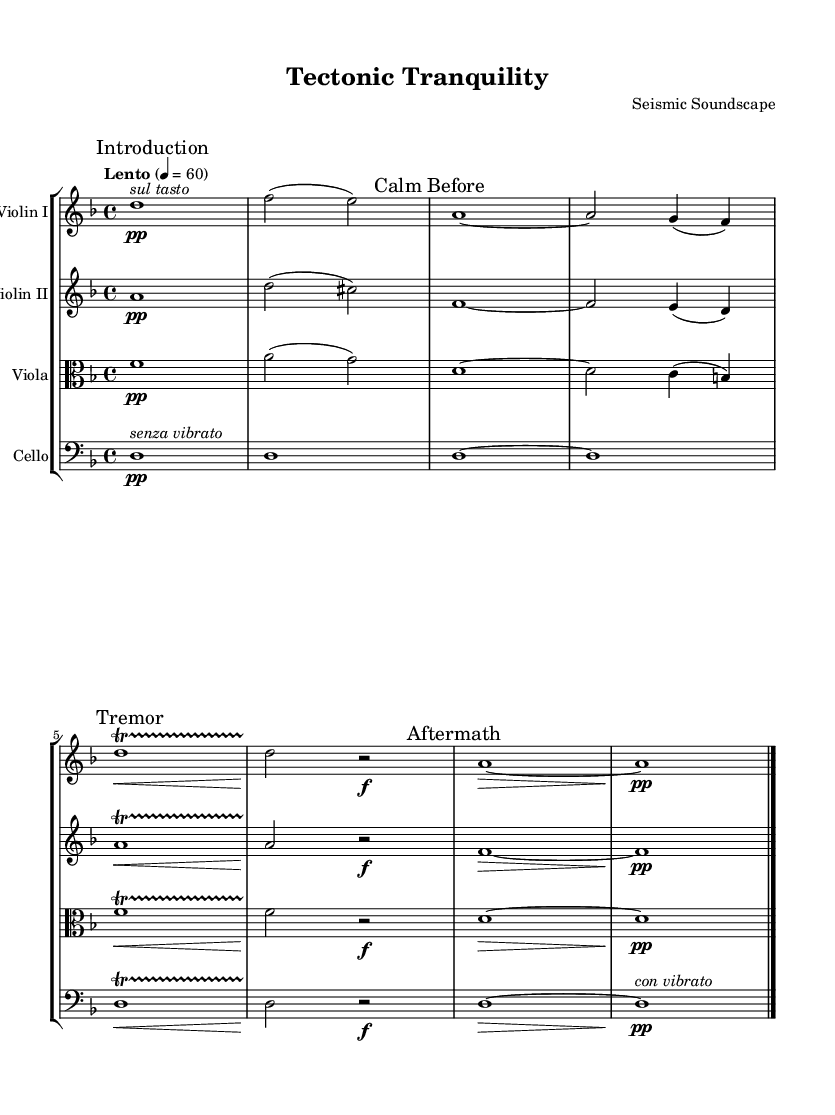What is the key signature of this music? The key signature is indicated at the beginning of the score, showing two flats (B♭ and E♭), which corresponds to D minor key.
Answer: D minor What is the time signature of this music? The time signature is found at the beginning of the score, marked as 4/4, indicating four beats per measure.
Answer: 4/4 What is the tempo marking for this piece? The tempo marking is specified in the global section of the score as "Lento," which indicates a slow tempo, set to 60 beats per minute.
Answer: Lento How many measures are in the introduction section? The introduction consists of one measure before the first mark "Calm Before," which indicates its ending.
Answer: 1 Which instrument part begins with "Introduction"? The violin I part starts with "Introduction," indicating the section that begins its melody first.
Answer: Violin I How is the dynamic marked in the "Afternmath" section? The dynamic marking in the "Afternmath" section shows a crescendo followed by a pianissimo marking indicated by ">" and "pp."
Answer: pp What performance technique is indicated for the cello part at the beginning? The cello part specifies "senza vibrato" at the beginning, meaning to play without vibrato for a calm effect.
Answer: senza vibrato 